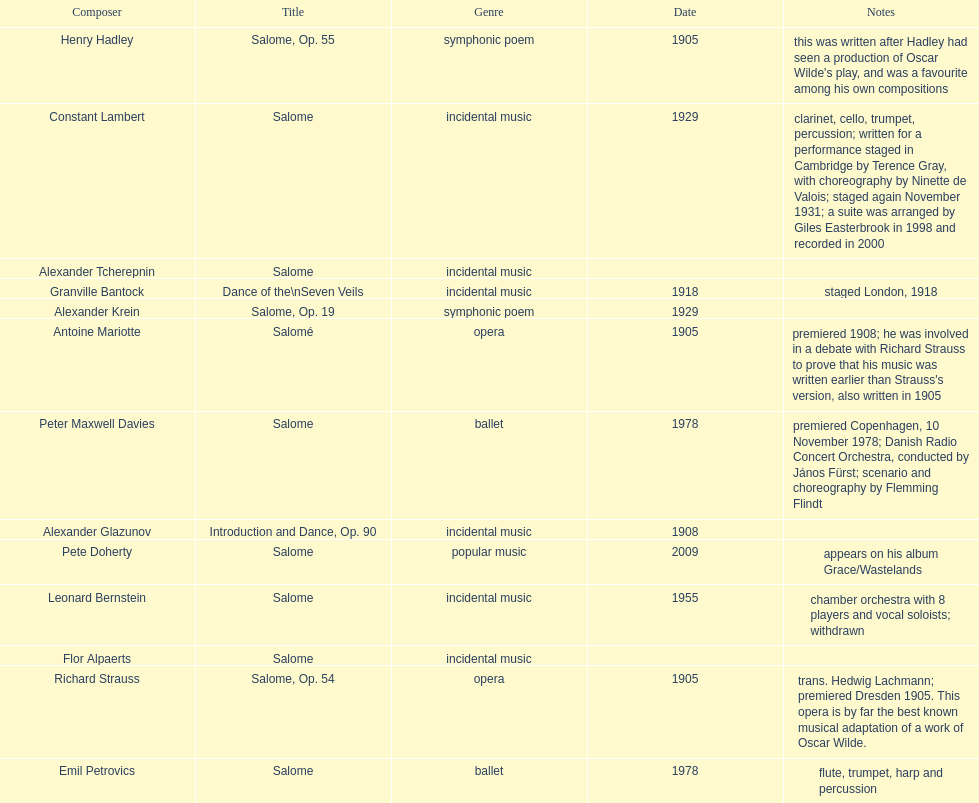How many works were made in the incidental music genre? 6. 